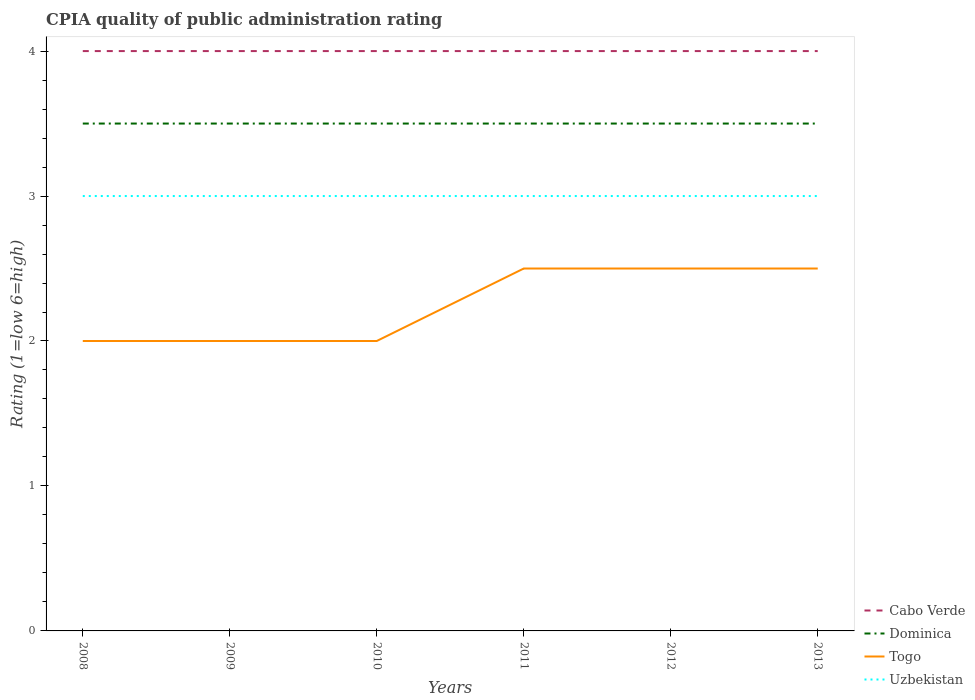Does the line corresponding to Cabo Verde intersect with the line corresponding to Dominica?
Provide a succinct answer. No. In which year was the CPIA rating in Cabo Verde maximum?
Give a very brief answer. 2008. What is the total CPIA rating in Dominica in the graph?
Your answer should be very brief. 0. How many years are there in the graph?
Keep it short and to the point. 6. What is the difference between two consecutive major ticks on the Y-axis?
Give a very brief answer. 1. Are the values on the major ticks of Y-axis written in scientific E-notation?
Offer a terse response. No. Does the graph contain any zero values?
Ensure brevity in your answer.  No. Does the graph contain grids?
Make the answer very short. No. Where does the legend appear in the graph?
Your response must be concise. Bottom right. What is the title of the graph?
Keep it short and to the point. CPIA quality of public administration rating. What is the label or title of the X-axis?
Your answer should be compact. Years. What is the label or title of the Y-axis?
Provide a short and direct response. Rating (1=low 6=high). What is the Rating (1=low 6=high) of Dominica in 2008?
Provide a succinct answer. 3.5. What is the Rating (1=low 6=high) of Uzbekistan in 2008?
Offer a terse response. 3. What is the Rating (1=low 6=high) in Cabo Verde in 2009?
Offer a terse response. 4. What is the Rating (1=low 6=high) of Togo in 2009?
Keep it short and to the point. 2. What is the Rating (1=low 6=high) in Cabo Verde in 2010?
Ensure brevity in your answer.  4. What is the Rating (1=low 6=high) of Dominica in 2010?
Ensure brevity in your answer.  3.5. What is the Rating (1=low 6=high) of Cabo Verde in 2011?
Keep it short and to the point. 4. What is the Rating (1=low 6=high) in Togo in 2011?
Your answer should be compact. 2.5. What is the Rating (1=low 6=high) of Uzbekistan in 2011?
Make the answer very short. 3. What is the Rating (1=low 6=high) of Uzbekistan in 2012?
Your response must be concise. 3. What is the Rating (1=low 6=high) of Togo in 2013?
Ensure brevity in your answer.  2.5. What is the Rating (1=low 6=high) in Uzbekistan in 2013?
Your answer should be very brief. 3. Across all years, what is the maximum Rating (1=low 6=high) in Cabo Verde?
Provide a short and direct response. 4. Across all years, what is the maximum Rating (1=low 6=high) of Uzbekistan?
Provide a succinct answer. 3. Across all years, what is the minimum Rating (1=low 6=high) in Cabo Verde?
Provide a succinct answer. 4. Across all years, what is the minimum Rating (1=low 6=high) of Uzbekistan?
Give a very brief answer. 3. What is the total Rating (1=low 6=high) in Dominica in the graph?
Your response must be concise. 21. What is the total Rating (1=low 6=high) in Uzbekistan in the graph?
Ensure brevity in your answer.  18. What is the difference between the Rating (1=low 6=high) of Togo in 2008 and that in 2009?
Give a very brief answer. 0. What is the difference between the Rating (1=low 6=high) of Cabo Verde in 2008 and that in 2010?
Provide a succinct answer. 0. What is the difference between the Rating (1=low 6=high) in Dominica in 2008 and that in 2010?
Your response must be concise. 0. What is the difference between the Rating (1=low 6=high) of Dominica in 2008 and that in 2011?
Offer a terse response. 0. What is the difference between the Rating (1=low 6=high) in Cabo Verde in 2008 and that in 2013?
Provide a succinct answer. 0. What is the difference between the Rating (1=low 6=high) of Dominica in 2008 and that in 2013?
Make the answer very short. 0. What is the difference between the Rating (1=low 6=high) of Uzbekistan in 2009 and that in 2010?
Make the answer very short. 0. What is the difference between the Rating (1=low 6=high) of Dominica in 2009 and that in 2011?
Provide a succinct answer. 0. What is the difference between the Rating (1=low 6=high) in Uzbekistan in 2009 and that in 2011?
Your answer should be compact. 0. What is the difference between the Rating (1=low 6=high) of Dominica in 2009 and that in 2012?
Offer a terse response. 0. What is the difference between the Rating (1=low 6=high) in Dominica in 2009 and that in 2013?
Keep it short and to the point. 0. What is the difference between the Rating (1=low 6=high) of Dominica in 2010 and that in 2011?
Keep it short and to the point. 0. What is the difference between the Rating (1=low 6=high) of Togo in 2010 and that in 2011?
Offer a very short reply. -0.5. What is the difference between the Rating (1=low 6=high) in Dominica in 2010 and that in 2012?
Give a very brief answer. 0. What is the difference between the Rating (1=low 6=high) of Togo in 2010 and that in 2012?
Ensure brevity in your answer.  -0.5. What is the difference between the Rating (1=low 6=high) in Dominica in 2010 and that in 2013?
Offer a very short reply. 0. What is the difference between the Rating (1=low 6=high) in Togo in 2010 and that in 2013?
Your response must be concise. -0.5. What is the difference between the Rating (1=low 6=high) of Uzbekistan in 2010 and that in 2013?
Make the answer very short. 0. What is the difference between the Rating (1=low 6=high) of Togo in 2011 and that in 2012?
Keep it short and to the point. 0. What is the difference between the Rating (1=low 6=high) in Uzbekistan in 2011 and that in 2012?
Make the answer very short. 0. What is the difference between the Rating (1=low 6=high) in Cabo Verde in 2011 and that in 2013?
Give a very brief answer. 0. What is the difference between the Rating (1=low 6=high) of Togo in 2011 and that in 2013?
Your response must be concise. 0. What is the difference between the Rating (1=low 6=high) in Cabo Verde in 2012 and that in 2013?
Provide a succinct answer. 0. What is the difference between the Rating (1=low 6=high) of Cabo Verde in 2008 and the Rating (1=low 6=high) of Uzbekistan in 2009?
Offer a terse response. 1. What is the difference between the Rating (1=low 6=high) of Dominica in 2008 and the Rating (1=low 6=high) of Togo in 2009?
Keep it short and to the point. 1.5. What is the difference between the Rating (1=low 6=high) in Dominica in 2008 and the Rating (1=low 6=high) in Uzbekistan in 2009?
Keep it short and to the point. 0.5. What is the difference between the Rating (1=low 6=high) in Cabo Verde in 2008 and the Rating (1=low 6=high) in Dominica in 2010?
Keep it short and to the point. 0.5. What is the difference between the Rating (1=low 6=high) in Cabo Verde in 2008 and the Rating (1=low 6=high) in Togo in 2010?
Your answer should be very brief. 2. What is the difference between the Rating (1=low 6=high) in Dominica in 2008 and the Rating (1=low 6=high) in Togo in 2010?
Make the answer very short. 1.5. What is the difference between the Rating (1=low 6=high) of Togo in 2008 and the Rating (1=low 6=high) of Uzbekistan in 2010?
Make the answer very short. -1. What is the difference between the Rating (1=low 6=high) of Cabo Verde in 2008 and the Rating (1=low 6=high) of Dominica in 2011?
Give a very brief answer. 0.5. What is the difference between the Rating (1=low 6=high) in Dominica in 2008 and the Rating (1=low 6=high) in Togo in 2011?
Ensure brevity in your answer.  1. What is the difference between the Rating (1=low 6=high) in Dominica in 2008 and the Rating (1=low 6=high) in Uzbekistan in 2011?
Your answer should be compact. 0.5. What is the difference between the Rating (1=low 6=high) in Dominica in 2008 and the Rating (1=low 6=high) in Togo in 2012?
Provide a succinct answer. 1. What is the difference between the Rating (1=low 6=high) of Togo in 2008 and the Rating (1=low 6=high) of Uzbekistan in 2012?
Provide a short and direct response. -1. What is the difference between the Rating (1=low 6=high) of Cabo Verde in 2008 and the Rating (1=low 6=high) of Togo in 2013?
Provide a succinct answer. 1.5. What is the difference between the Rating (1=low 6=high) of Cabo Verde in 2008 and the Rating (1=low 6=high) of Uzbekistan in 2013?
Ensure brevity in your answer.  1. What is the difference between the Rating (1=low 6=high) of Cabo Verde in 2009 and the Rating (1=low 6=high) of Dominica in 2010?
Offer a terse response. 0.5. What is the difference between the Rating (1=low 6=high) of Cabo Verde in 2009 and the Rating (1=low 6=high) of Togo in 2010?
Your response must be concise. 2. What is the difference between the Rating (1=low 6=high) in Cabo Verde in 2009 and the Rating (1=low 6=high) in Uzbekistan in 2010?
Make the answer very short. 1. What is the difference between the Rating (1=low 6=high) in Cabo Verde in 2009 and the Rating (1=low 6=high) in Uzbekistan in 2011?
Your response must be concise. 1. What is the difference between the Rating (1=low 6=high) in Dominica in 2009 and the Rating (1=low 6=high) in Togo in 2011?
Your answer should be compact. 1. What is the difference between the Rating (1=low 6=high) in Dominica in 2009 and the Rating (1=low 6=high) in Uzbekistan in 2011?
Offer a very short reply. 0.5. What is the difference between the Rating (1=low 6=high) of Togo in 2009 and the Rating (1=low 6=high) of Uzbekistan in 2011?
Offer a terse response. -1. What is the difference between the Rating (1=low 6=high) of Cabo Verde in 2009 and the Rating (1=low 6=high) of Dominica in 2012?
Ensure brevity in your answer.  0.5. What is the difference between the Rating (1=low 6=high) of Cabo Verde in 2009 and the Rating (1=low 6=high) of Togo in 2012?
Make the answer very short. 1.5. What is the difference between the Rating (1=low 6=high) of Cabo Verde in 2009 and the Rating (1=low 6=high) of Uzbekistan in 2012?
Give a very brief answer. 1. What is the difference between the Rating (1=low 6=high) in Dominica in 2009 and the Rating (1=low 6=high) in Togo in 2013?
Your answer should be very brief. 1. What is the difference between the Rating (1=low 6=high) in Cabo Verde in 2010 and the Rating (1=low 6=high) in Togo in 2011?
Ensure brevity in your answer.  1.5. What is the difference between the Rating (1=low 6=high) of Cabo Verde in 2010 and the Rating (1=low 6=high) of Uzbekistan in 2011?
Give a very brief answer. 1. What is the difference between the Rating (1=low 6=high) in Dominica in 2010 and the Rating (1=low 6=high) in Uzbekistan in 2011?
Offer a very short reply. 0.5. What is the difference between the Rating (1=low 6=high) of Togo in 2010 and the Rating (1=low 6=high) of Uzbekistan in 2011?
Offer a terse response. -1. What is the difference between the Rating (1=low 6=high) of Dominica in 2010 and the Rating (1=low 6=high) of Uzbekistan in 2012?
Give a very brief answer. 0.5. What is the difference between the Rating (1=low 6=high) of Cabo Verde in 2010 and the Rating (1=low 6=high) of Dominica in 2013?
Offer a very short reply. 0.5. What is the difference between the Rating (1=low 6=high) of Cabo Verde in 2010 and the Rating (1=low 6=high) of Togo in 2013?
Keep it short and to the point. 1.5. What is the difference between the Rating (1=low 6=high) in Cabo Verde in 2010 and the Rating (1=low 6=high) in Uzbekistan in 2013?
Your answer should be very brief. 1. What is the difference between the Rating (1=low 6=high) in Dominica in 2010 and the Rating (1=low 6=high) in Uzbekistan in 2013?
Offer a terse response. 0.5. What is the difference between the Rating (1=low 6=high) of Cabo Verde in 2011 and the Rating (1=low 6=high) of Togo in 2012?
Offer a very short reply. 1.5. What is the difference between the Rating (1=low 6=high) of Cabo Verde in 2011 and the Rating (1=low 6=high) of Uzbekistan in 2012?
Make the answer very short. 1. What is the difference between the Rating (1=low 6=high) in Dominica in 2011 and the Rating (1=low 6=high) in Togo in 2012?
Provide a succinct answer. 1. What is the difference between the Rating (1=low 6=high) in Dominica in 2011 and the Rating (1=low 6=high) in Uzbekistan in 2012?
Your answer should be compact. 0.5. What is the difference between the Rating (1=low 6=high) in Togo in 2011 and the Rating (1=low 6=high) in Uzbekistan in 2012?
Ensure brevity in your answer.  -0.5. What is the difference between the Rating (1=low 6=high) in Cabo Verde in 2011 and the Rating (1=low 6=high) in Togo in 2013?
Provide a succinct answer. 1.5. What is the difference between the Rating (1=low 6=high) of Cabo Verde in 2011 and the Rating (1=low 6=high) of Uzbekistan in 2013?
Your response must be concise. 1. What is the difference between the Rating (1=low 6=high) of Togo in 2011 and the Rating (1=low 6=high) of Uzbekistan in 2013?
Offer a terse response. -0.5. What is the difference between the Rating (1=low 6=high) in Cabo Verde in 2012 and the Rating (1=low 6=high) in Dominica in 2013?
Offer a terse response. 0.5. What is the difference between the Rating (1=low 6=high) in Cabo Verde in 2012 and the Rating (1=low 6=high) in Togo in 2013?
Offer a terse response. 1.5. What is the average Rating (1=low 6=high) in Cabo Verde per year?
Offer a very short reply. 4. What is the average Rating (1=low 6=high) of Dominica per year?
Make the answer very short. 3.5. What is the average Rating (1=low 6=high) in Togo per year?
Your answer should be compact. 2.25. What is the average Rating (1=low 6=high) of Uzbekistan per year?
Your response must be concise. 3. In the year 2008, what is the difference between the Rating (1=low 6=high) of Cabo Verde and Rating (1=low 6=high) of Togo?
Provide a succinct answer. 2. In the year 2008, what is the difference between the Rating (1=low 6=high) in Cabo Verde and Rating (1=low 6=high) in Uzbekistan?
Your answer should be compact. 1. In the year 2008, what is the difference between the Rating (1=low 6=high) in Dominica and Rating (1=low 6=high) in Uzbekistan?
Offer a very short reply. 0.5. In the year 2009, what is the difference between the Rating (1=low 6=high) of Cabo Verde and Rating (1=low 6=high) of Dominica?
Ensure brevity in your answer.  0.5. In the year 2009, what is the difference between the Rating (1=low 6=high) in Dominica and Rating (1=low 6=high) in Togo?
Provide a succinct answer. 1.5. In the year 2009, what is the difference between the Rating (1=low 6=high) in Togo and Rating (1=low 6=high) in Uzbekistan?
Offer a terse response. -1. In the year 2010, what is the difference between the Rating (1=low 6=high) in Cabo Verde and Rating (1=low 6=high) in Dominica?
Your answer should be compact. 0.5. In the year 2010, what is the difference between the Rating (1=low 6=high) in Dominica and Rating (1=low 6=high) in Togo?
Keep it short and to the point. 1.5. In the year 2010, what is the difference between the Rating (1=low 6=high) in Togo and Rating (1=low 6=high) in Uzbekistan?
Provide a succinct answer. -1. In the year 2011, what is the difference between the Rating (1=low 6=high) of Cabo Verde and Rating (1=low 6=high) of Dominica?
Your answer should be very brief. 0.5. In the year 2011, what is the difference between the Rating (1=low 6=high) in Cabo Verde and Rating (1=low 6=high) in Togo?
Make the answer very short. 1.5. In the year 2011, what is the difference between the Rating (1=low 6=high) in Cabo Verde and Rating (1=low 6=high) in Uzbekistan?
Your answer should be very brief. 1. In the year 2011, what is the difference between the Rating (1=low 6=high) in Dominica and Rating (1=low 6=high) in Togo?
Provide a succinct answer. 1. In the year 2012, what is the difference between the Rating (1=low 6=high) in Cabo Verde and Rating (1=low 6=high) in Uzbekistan?
Your answer should be compact. 1. In the year 2012, what is the difference between the Rating (1=low 6=high) in Dominica and Rating (1=low 6=high) in Uzbekistan?
Ensure brevity in your answer.  0.5. In the year 2012, what is the difference between the Rating (1=low 6=high) of Togo and Rating (1=low 6=high) of Uzbekistan?
Give a very brief answer. -0.5. In the year 2013, what is the difference between the Rating (1=low 6=high) in Cabo Verde and Rating (1=low 6=high) in Togo?
Offer a terse response. 1.5. In the year 2013, what is the difference between the Rating (1=low 6=high) in Cabo Verde and Rating (1=low 6=high) in Uzbekistan?
Give a very brief answer. 1. In the year 2013, what is the difference between the Rating (1=low 6=high) of Dominica and Rating (1=low 6=high) of Togo?
Make the answer very short. 1. In the year 2013, what is the difference between the Rating (1=low 6=high) of Togo and Rating (1=low 6=high) of Uzbekistan?
Make the answer very short. -0.5. What is the ratio of the Rating (1=low 6=high) in Cabo Verde in 2008 to that in 2009?
Offer a terse response. 1. What is the ratio of the Rating (1=low 6=high) of Dominica in 2008 to that in 2009?
Keep it short and to the point. 1. What is the ratio of the Rating (1=low 6=high) in Togo in 2008 to that in 2009?
Keep it short and to the point. 1. What is the ratio of the Rating (1=low 6=high) in Cabo Verde in 2008 to that in 2010?
Give a very brief answer. 1. What is the ratio of the Rating (1=low 6=high) of Uzbekistan in 2008 to that in 2010?
Your answer should be very brief. 1. What is the ratio of the Rating (1=low 6=high) in Cabo Verde in 2008 to that in 2011?
Make the answer very short. 1. What is the ratio of the Rating (1=low 6=high) of Dominica in 2008 to that in 2011?
Your answer should be compact. 1. What is the ratio of the Rating (1=low 6=high) of Togo in 2008 to that in 2011?
Offer a terse response. 0.8. What is the ratio of the Rating (1=low 6=high) of Uzbekistan in 2008 to that in 2011?
Your answer should be very brief. 1. What is the ratio of the Rating (1=low 6=high) of Dominica in 2008 to that in 2012?
Offer a terse response. 1. What is the ratio of the Rating (1=low 6=high) in Togo in 2008 to that in 2012?
Ensure brevity in your answer.  0.8. What is the ratio of the Rating (1=low 6=high) of Uzbekistan in 2008 to that in 2012?
Keep it short and to the point. 1. What is the ratio of the Rating (1=low 6=high) of Cabo Verde in 2008 to that in 2013?
Your answer should be compact. 1. What is the ratio of the Rating (1=low 6=high) of Togo in 2008 to that in 2013?
Keep it short and to the point. 0.8. What is the ratio of the Rating (1=low 6=high) in Cabo Verde in 2009 to that in 2010?
Keep it short and to the point. 1. What is the ratio of the Rating (1=low 6=high) of Dominica in 2009 to that in 2010?
Offer a terse response. 1. What is the ratio of the Rating (1=low 6=high) of Togo in 2009 to that in 2010?
Your response must be concise. 1. What is the ratio of the Rating (1=low 6=high) of Uzbekistan in 2009 to that in 2010?
Your answer should be compact. 1. What is the ratio of the Rating (1=low 6=high) in Cabo Verde in 2009 to that in 2011?
Provide a short and direct response. 1. What is the ratio of the Rating (1=low 6=high) in Togo in 2009 to that in 2011?
Ensure brevity in your answer.  0.8. What is the ratio of the Rating (1=low 6=high) in Uzbekistan in 2009 to that in 2012?
Keep it short and to the point. 1. What is the ratio of the Rating (1=low 6=high) in Cabo Verde in 2009 to that in 2013?
Provide a short and direct response. 1. What is the ratio of the Rating (1=low 6=high) of Dominica in 2009 to that in 2013?
Your answer should be very brief. 1. What is the ratio of the Rating (1=low 6=high) in Togo in 2009 to that in 2013?
Offer a terse response. 0.8. What is the ratio of the Rating (1=low 6=high) of Uzbekistan in 2009 to that in 2013?
Ensure brevity in your answer.  1. What is the ratio of the Rating (1=low 6=high) of Dominica in 2010 to that in 2011?
Provide a succinct answer. 1. What is the ratio of the Rating (1=low 6=high) in Uzbekistan in 2010 to that in 2011?
Provide a succinct answer. 1. What is the ratio of the Rating (1=low 6=high) of Togo in 2010 to that in 2012?
Ensure brevity in your answer.  0.8. What is the ratio of the Rating (1=low 6=high) in Uzbekistan in 2010 to that in 2012?
Offer a very short reply. 1. What is the ratio of the Rating (1=low 6=high) in Dominica in 2010 to that in 2013?
Your response must be concise. 1. What is the ratio of the Rating (1=low 6=high) in Uzbekistan in 2010 to that in 2013?
Ensure brevity in your answer.  1. What is the ratio of the Rating (1=low 6=high) of Togo in 2011 to that in 2012?
Provide a succinct answer. 1. What is the ratio of the Rating (1=low 6=high) of Uzbekistan in 2011 to that in 2012?
Provide a succinct answer. 1. What is the ratio of the Rating (1=low 6=high) of Cabo Verde in 2011 to that in 2013?
Your response must be concise. 1. What is the ratio of the Rating (1=low 6=high) in Dominica in 2011 to that in 2013?
Give a very brief answer. 1. What is the ratio of the Rating (1=low 6=high) in Cabo Verde in 2012 to that in 2013?
Ensure brevity in your answer.  1. What is the ratio of the Rating (1=low 6=high) in Togo in 2012 to that in 2013?
Your response must be concise. 1. What is the ratio of the Rating (1=low 6=high) of Uzbekistan in 2012 to that in 2013?
Provide a succinct answer. 1. What is the difference between the highest and the second highest Rating (1=low 6=high) of Cabo Verde?
Provide a short and direct response. 0. What is the difference between the highest and the lowest Rating (1=low 6=high) of Togo?
Keep it short and to the point. 0.5. 